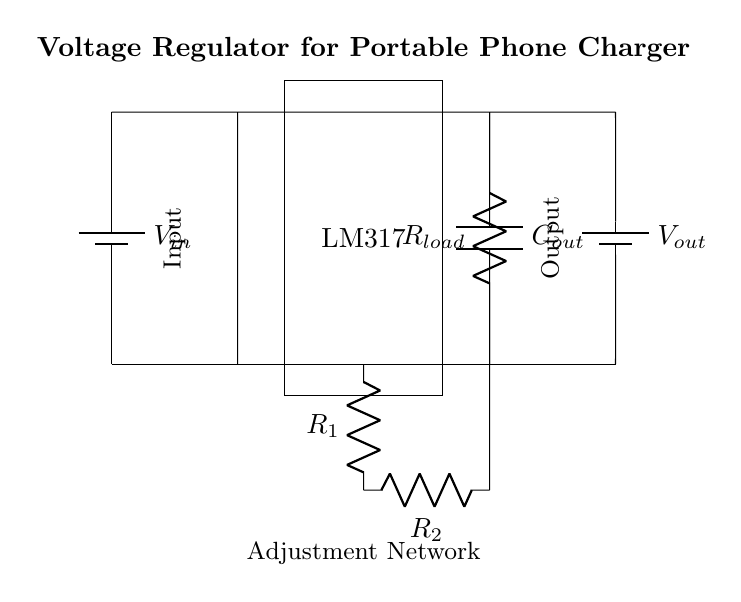What is the input voltage of the circuit? The input voltage is labeled as Vin in the circuit diagram indicating that it is the voltage source providing the input to the regulator.
Answer: Vin What component is used for voltage regulation? The component used for voltage regulation is labeled as LM317 in the circuit diagram, which indicates it is a voltage regulator IC.
Answer: LM317 What are the adjustment resistors labeled in the circuit? The adjustment resistors are labeled as R1 and R2 in the circuit diagram, indicating their function in setting the output voltage.
Answer: R1, R2 What type of capacitor is used in the output section? The capacitor used in the output section is labeled as Cout in the circuit diagram, indicating it is an output capacitor.
Answer: Cout What is the load connected to the output? The load connected to the output is indicated by a resistor labeled Rload, which shows the device being powered by the regulator.
Answer: Rload What is the relationship between Vin and Vout in this circuit? The LM317 works to maintain a fixed output voltage (Vout) regardless of the variations in input voltage (Vin), demonstrating its regulation capability.
Answer: Regulated output What happens if R1 and R2 are changed in the circuit? Changing R1 and R2 adjusts the output voltage (Vout) produced by the LM317 since they are part of the voltage adjustment network in the circuit.
Answer: Adjusts Vout 